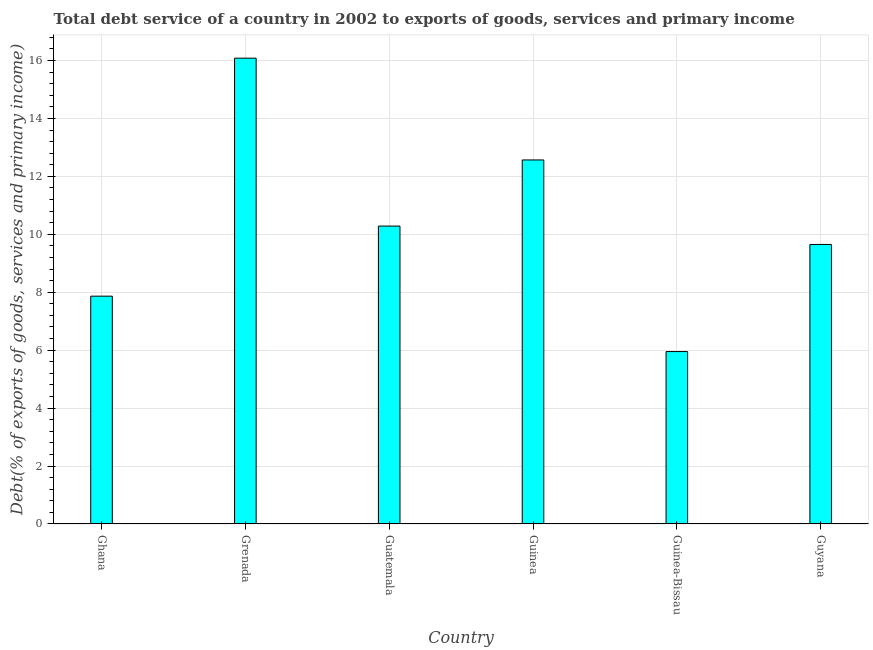Does the graph contain any zero values?
Your response must be concise. No. Does the graph contain grids?
Provide a succinct answer. Yes. What is the title of the graph?
Your answer should be very brief. Total debt service of a country in 2002 to exports of goods, services and primary income. What is the label or title of the Y-axis?
Provide a succinct answer. Debt(% of exports of goods, services and primary income). What is the total debt service in Guyana?
Keep it short and to the point. 9.65. Across all countries, what is the maximum total debt service?
Offer a very short reply. 16.08. Across all countries, what is the minimum total debt service?
Offer a terse response. 5.95. In which country was the total debt service maximum?
Make the answer very short. Grenada. In which country was the total debt service minimum?
Ensure brevity in your answer.  Guinea-Bissau. What is the sum of the total debt service?
Your response must be concise. 62.4. What is the difference between the total debt service in Guinea and Guinea-Bissau?
Your answer should be compact. 6.62. What is the average total debt service per country?
Offer a terse response. 10.4. What is the median total debt service?
Your answer should be very brief. 9.97. In how many countries, is the total debt service greater than 8.4 %?
Make the answer very short. 4. What is the ratio of the total debt service in Guatemala to that in Guyana?
Offer a very short reply. 1.07. Is the total debt service in Grenada less than that in Guyana?
Your response must be concise. No. Is the difference between the total debt service in Ghana and Guinea greater than the difference between any two countries?
Your answer should be very brief. No. What is the difference between the highest and the second highest total debt service?
Make the answer very short. 3.51. What is the difference between the highest and the lowest total debt service?
Give a very brief answer. 10.13. Are all the bars in the graph horizontal?
Your response must be concise. No. What is the Debt(% of exports of goods, services and primary income) in Ghana?
Offer a terse response. 7.86. What is the Debt(% of exports of goods, services and primary income) in Grenada?
Give a very brief answer. 16.08. What is the Debt(% of exports of goods, services and primary income) of Guatemala?
Your answer should be compact. 10.28. What is the Debt(% of exports of goods, services and primary income) in Guinea?
Offer a terse response. 12.57. What is the Debt(% of exports of goods, services and primary income) of Guinea-Bissau?
Ensure brevity in your answer.  5.95. What is the Debt(% of exports of goods, services and primary income) in Guyana?
Provide a succinct answer. 9.65. What is the difference between the Debt(% of exports of goods, services and primary income) in Ghana and Grenada?
Your answer should be compact. -8.22. What is the difference between the Debt(% of exports of goods, services and primary income) in Ghana and Guatemala?
Ensure brevity in your answer.  -2.42. What is the difference between the Debt(% of exports of goods, services and primary income) in Ghana and Guinea?
Provide a succinct answer. -4.7. What is the difference between the Debt(% of exports of goods, services and primary income) in Ghana and Guinea-Bissau?
Ensure brevity in your answer.  1.91. What is the difference between the Debt(% of exports of goods, services and primary income) in Ghana and Guyana?
Your response must be concise. -1.79. What is the difference between the Debt(% of exports of goods, services and primary income) in Grenada and Guatemala?
Offer a terse response. 5.8. What is the difference between the Debt(% of exports of goods, services and primary income) in Grenada and Guinea?
Keep it short and to the point. 3.51. What is the difference between the Debt(% of exports of goods, services and primary income) in Grenada and Guinea-Bissau?
Offer a very short reply. 10.13. What is the difference between the Debt(% of exports of goods, services and primary income) in Grenada and Guyana?
Your answer should be very brief. 6.43. What is the difference between the Debt(% of exports of goods, services and primary income) in Guatemala and Guinea?
Your answer should be very brief. -2.28. What is the difference between the Debt(% of exports of goods, services and primary income) in Guatemala and Guinea-Bissau?
Ensure brevity in your answer.  4.33. What is the difference between the Debt(% of exports of goods, services and primary income) in Guatemala and Guyana?
Your response must be concise. 0.63. What is the difference between the Debt(% of exports of goods, services and primary income) in Guinea and Guinea-Bissau?
Your answer should be very brief. 6.62. What is the difference between the Debt(% of exports of goods, services and primary income) in Guinea and Guyana?
Your answer should be compact. 2.92. What is the difference between the Debt(% of exports of goods, services and primary income) in Guinea-Bissau and Guyana?
Offer a very short reply. -3.7. What is the ratio of the Debt(% of exports of goods, services and primary income) in Ghana to that in Grenada?
Your answer should be compact. 0.49. What is the ratio of the Debt(% of exports of goods, services and primary income) in Ghana to that in Guatemala?
Offer a very short reply. 0.77. What is the ratio of the Debt(% of exports of goods, services and primary income) in Ghana to that in Guinea?
Offer a very short reply. 0.63. What is the ratio of the Debt(% of exports of goods, services and primary income) in Ghana to that in Guinea-Bissau?
Give a very brief answer. 1.32. What is the ratio of the Debt(% of exports of goods, services and primary income) in Ghana to that in Guyana?
Your answer should be compact. 0.81. What is the ratio of the Debt(% of exports of goods, services and primary income) in Grenada to that in Guatemala?
Give a very brief answer. 1.56. What is the ratio of the Debt(% of exports of goods, services and primary income) in Grenada to that in Guinea?
Provide a short and direct response. 1.28. What is the ratio of the Debt(% of exports of goods, services and primary income) in Grenada to that in Guinea-Bissau?
Provide a short and direct response. 2.7. What is the ratio of the Debt(% of exports of goods, services and primary income) in Grenada to that in Guyana?
Offer a very short reply. 1.67. What is the ratio of the Debt(% of exports of goods, services and primary income) in Guatemala to that in Guinea?
Offer a very short reply. 0.82. What is the ratio of the Debt(% of exports of goods, services and primary income) in Guatemala to that in Guinea-Bissau?
Offer a terse response. 1.73. What is the ratio of the Debt(% of exports of goods, services and primary income) in Guatemala to that in Guyana?
Your response must be concise. 1.07. What is the ratio of the Debt(% of exports of goods, services and primary income) in Guinea to that in Guinea-Bissau?
Offer a very short reply. 2.11. What is the ratio of the Debt(% of exports of goods, services and primary income) in Guinea to that in Guyana?
Make the answer very short. 1.3. What is the ratio of the Debt(% of exports of goods, services and primary income) in Guinea-Bissau to that in Guyana?
Ensure brevity in your answer.  0.62. 